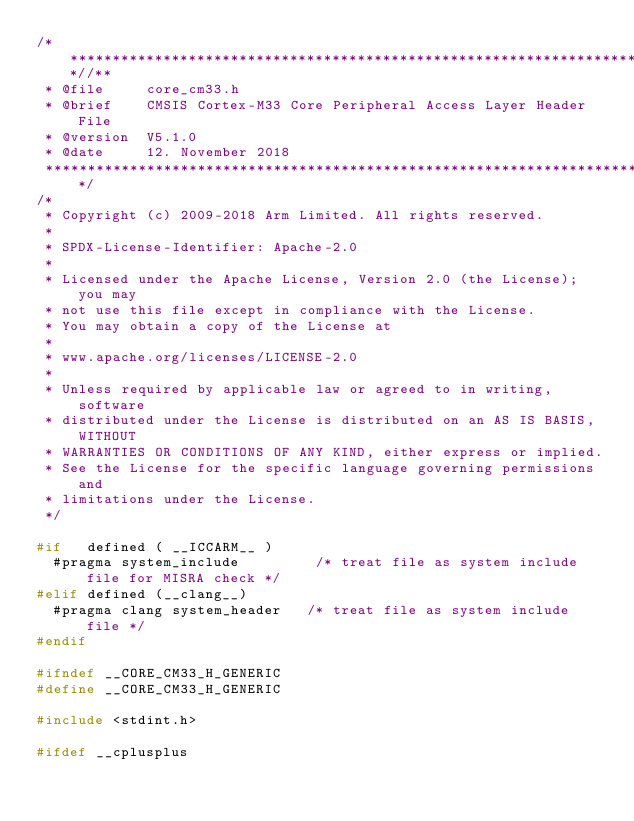<code> <loc_0><loc_0><loc_500><loc_500><_C_>/**************************************************************************//**
 * @file     core_cm33.h
 * @brief    CMSIS Cortex-M33 Core Peripheral Access Layer Header File
 * @version  V5.1.0
 * @date     12. November 2018
 ******************************************************************************/
/*
 * Copyright (c) 2009-2018 Arm Limited. All rights reserved.
 *
 * SPDX-License-Identifier: Apache-2.0
 *
 * Licensed under the Apache License, Version 2.0 (the License); you may
 * not use this file except in compliance with the License.
 * You may obtain a copy of the License at
 *
 * www.apache.org/licenses/LICENSE-2.0
 *
 * Unless required by applicable law or agreed to in writing, software
 * distributed under the License is distributed on an AS IS BASIS, WITHOUT
 * WARRANTIES OR CONDITIONS OF ANY KIND, either express or implied.
 * See the License for the specific language governing permissions and
 * limitations under the License.
 */

#if   defined ( __ICCARM__ )
  #pragma system_include         /* treat file as system include file for MISRA check */
#elif defined (__clang__)
  #pragma clang system_header   /* treat file as system include file */
#endif

#ifndef __CORE_CM33_H_GENERIC
#define __CORE_CM33_H_GENERIC

#include <stdint.h>

#ifdef __cplusplus</code> 